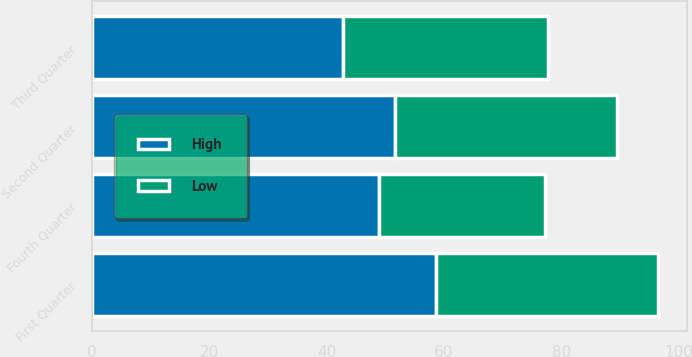<chart> <loc_0><loc_0><loc_500><loc_500><stacked_bar_chart><ecel><fcel>First Quarter<fcel>Second Quarter<fcel>Third Quarter<fcel>Fourth Quarter<nl><fcel>High<fcel>58.64<fcel>51.58<fcel>42.8<fcel>48.98<nl><fcel>Low<fcel>37.9<fcel>38<fcel>34.99<fcel>28.22<nl></chart> 